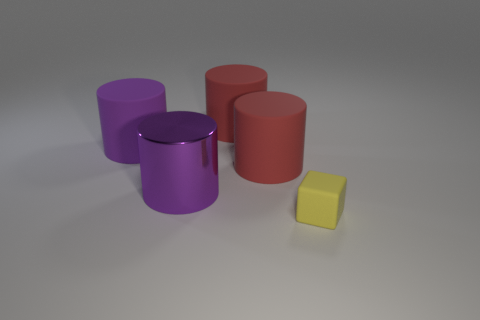What material do the objects seem to be made of? The objects in the image have a matte finish and consistent texture, suggesting they could be made of a type of plastic or painted wood. There's no reflection or sheen that would imply a metallic or glass material. 